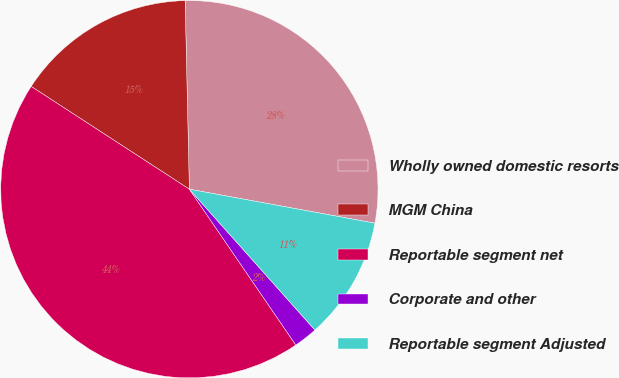Convert chart. <chart><loc_0><loc_0><loc_500><loc_500><pie_chart><fcel>Wholly owned domestic resorts<fcel>MGM China<fcel>Reportable segment net<fcel>Corporate and other<fcel>Reportable segment Adjusted<nl><fcel>28.24%<fcel>15.47%<fcel>43.71%<fcel>2.05%<fcel>10.53%<nl></chart> 